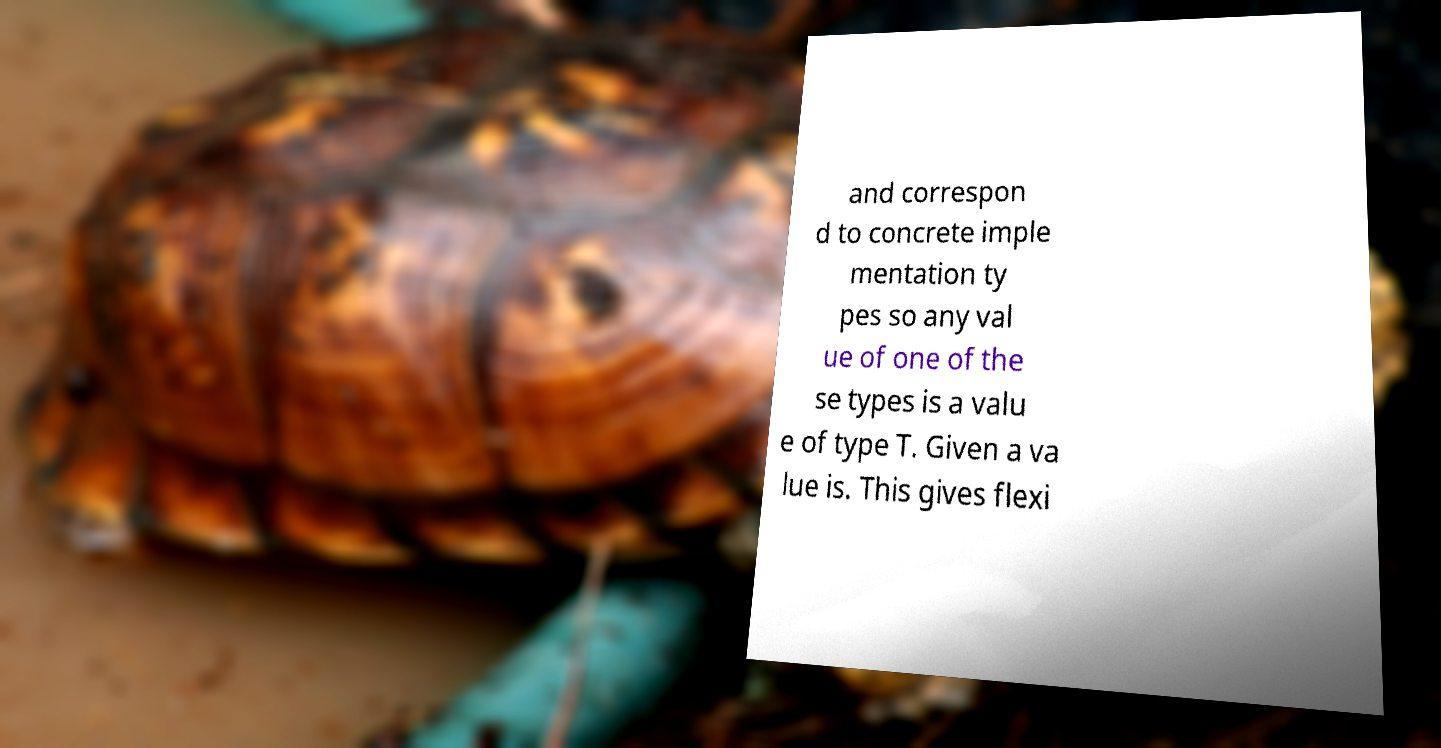Can you accurately transcribe the text from the provided image for me? and correspon d to concrete imple mentation ty pes so any val ue of one of the se types is a valu e of type T. Given a va lue is. This gives flexi 